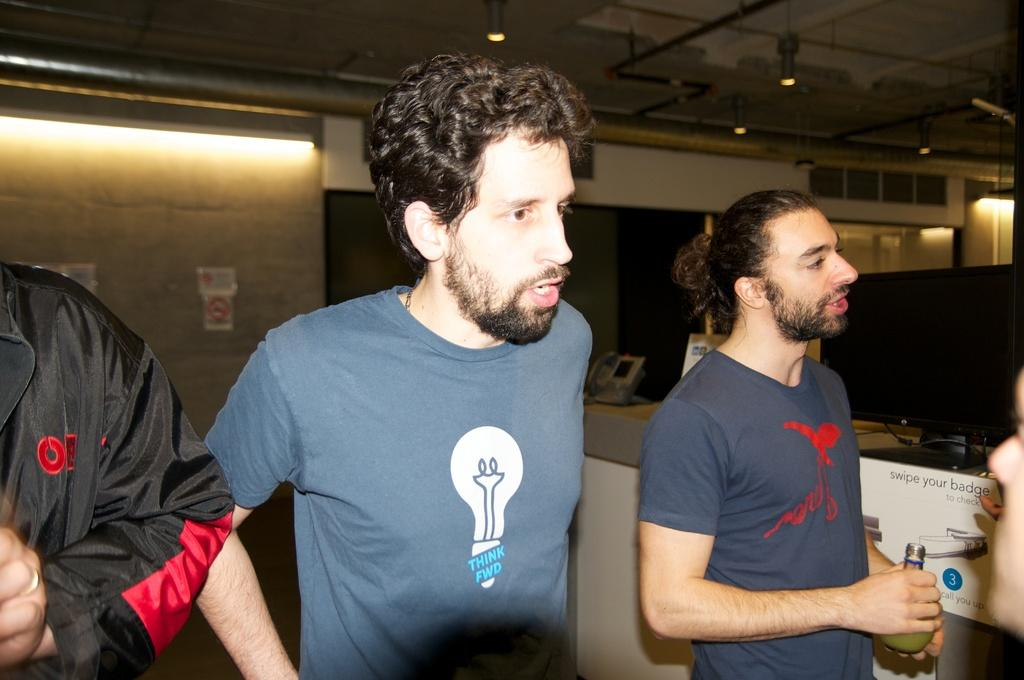<image>
Give a short and clear explanation of the subsequent image. Three people are standing next to a sign that says swipe your badge to check. 